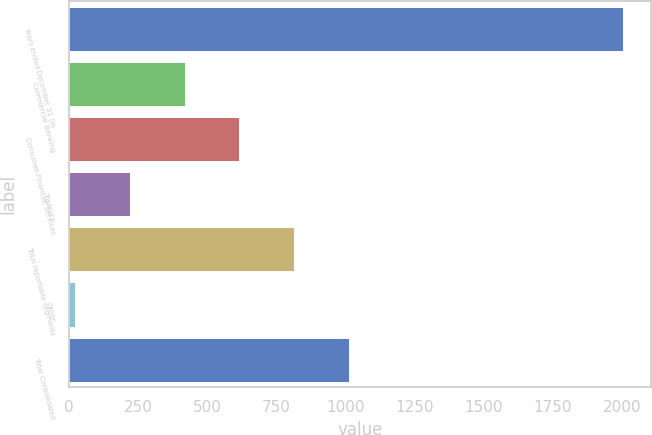<chart> <loc_0><loc_0><loc_500><loc_500><bar_chart><fcel>Years ended December 31 (in<fcel>Commercial Banking<fcel>Consumer Financial Services<fcel>Treasury<fcel>Total reportable segments<fcel>Other<fcel>Total Consolidated<nl><fcel>2005<fcel>418.76<fcel>617.04<fcel>220.48<fcel>815.32<fcel>22.2<fcel>1013.6<nl></chart> 